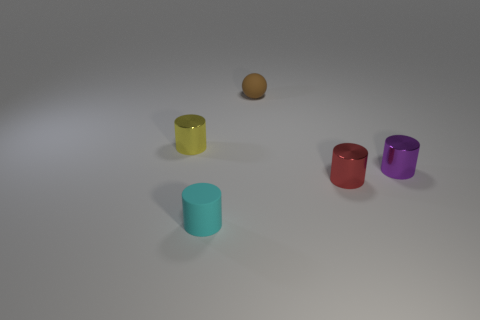The metallic object that is left of the thing that is behind the tiny yellow cylinder is what color?
Offer a very short reply. Yellow. Do the yellow object and the tiny thing right of the red metal cylinder have the same material?
Your response must be concise. Yes. The tiny metallic cylinder left of the rubber object that is to the right of the small cylinder in front of the red shiny thing is what color?
Provide a short and direct response. Yellow. Are there any other things that are the same shape as the small red metallic thing?
Your answer should be very brief. Yes. Is the number of large gray matte objects greater than the number of purple cylinders?
Offer a very short reply. No. What number of objects are both in front of the purple object and behind the purple shiny object?
Provide a short and direct response. 0. There is a cyan cylinder that is to the left of the rubber ball; what number of rubber objects are behind it?
Your answer should be very brief. 1. Do the shiny object on the right side of the small red shiny object and the object that is in front of the tiny red object have the same size?
Your answer should be compact. Yes. How many metal cylinders are there?
Offer a terse response. 3. How many red objects are made of the same material as the brown thing?
Ensure brevity in your answer.  0. 